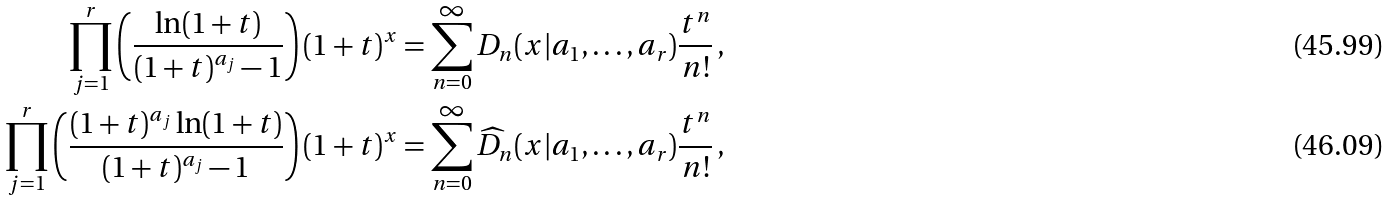Convert formula to latex. <formula><loc_0><loc_0><loc_500><loc_500>\prod _ { j = 1 } ^ { r } \left ( \frac { \ln ( 1 + t ) } { ( 1 + t ) ^ { a _ { j } } - 1 } \right ) ( 1 + t ) ^ { x } & = \sum _ { n = 0 } ^ { \infty } D _ { n } ( x | a _ { 1 } , \dots , a _ { r } ) \frac { t ^ { n } } { n ! } \, , \\ \prod _ { j = 1 } ^ { r } \left ( \frac { ( 1 + t ) ^ { a _ { j } } \ln ( 1 + t ) } { ( 1 + t ) ^ { a _ { j } } - 1 } \right ) ( 1 + t ) ^ { x } & = \sum _ { n = 0 } ^ { \infty } \widehat { D } _ { n } ( x | a _ { 1 } , \dots , a _ { r } ) \frac { t ^ { n } } { n ! } \, ,</formula> 